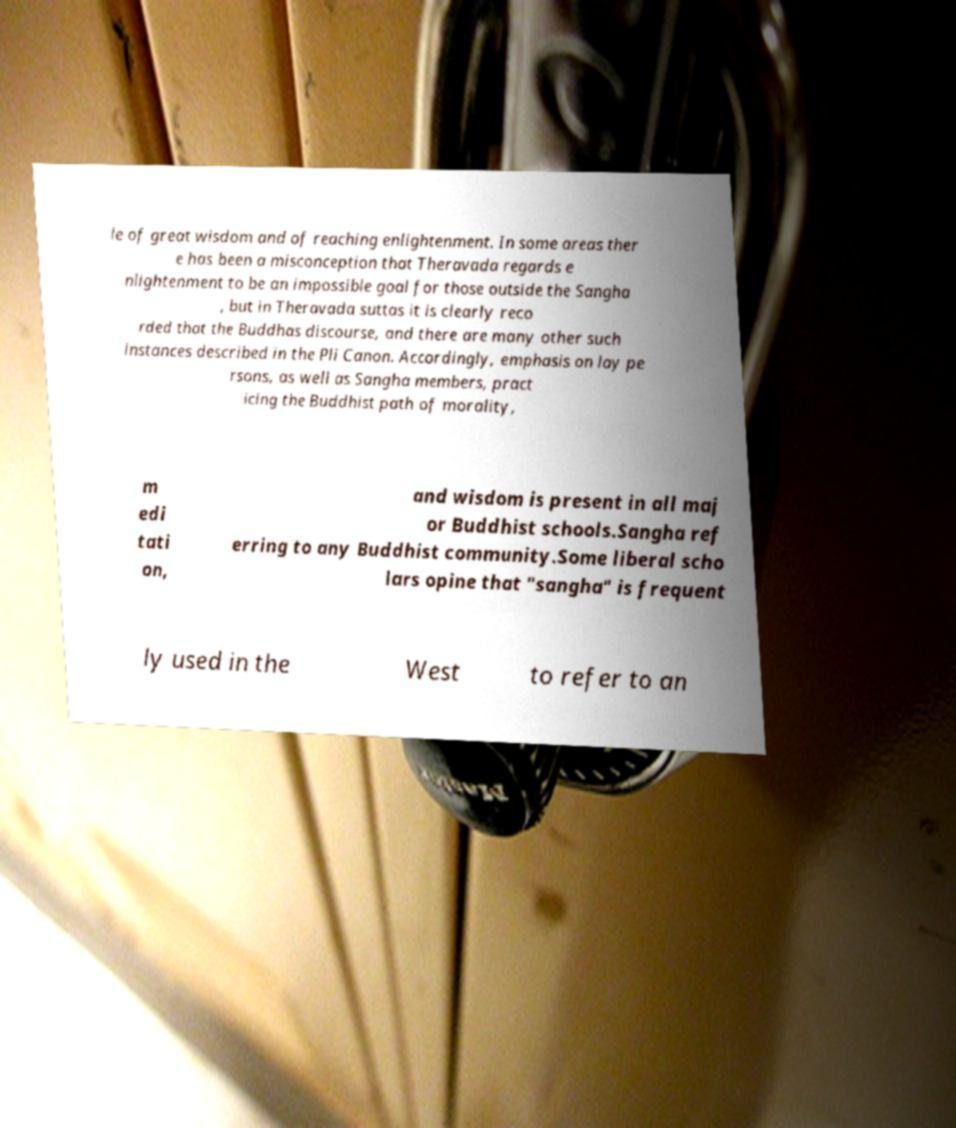For documentation purposes, I need the text within this image transcribed. Could you provide that? le of great wisdom and of reaching enlightenment. In some areas ther e has been a misconception that Theravada regards e nlightenment to be an impossible goal for those outside the Sangha , but in Theravada suttas it is clearly reco rded that the Buddhas discourse, and there are many other such instances described in the Pli Canon. Accordingly, emphasis on lay pe rsons, as well as Sangha members, pract icing the Buddhist path of morality, m edi tati on, and wisdom is present in all maj or Buddhist schools.Sangha ref erring to any Buddhist community.Some liberal scho lars opine that "sangha" is frequent ly used in the West to refer to an 